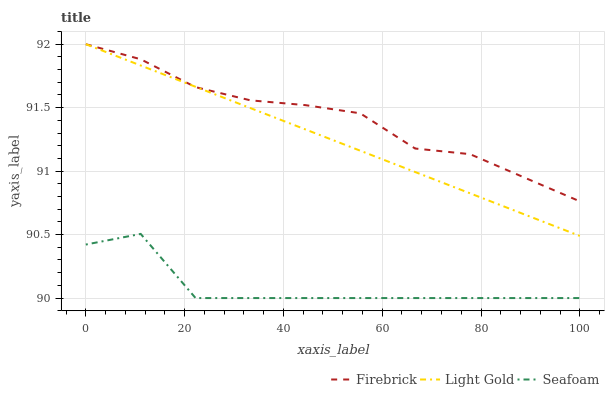Does Seafoam have the minimum area under the curve?
Answer yes or no. Yes. Does Firebrick have the maximum area under the curve?
Answer yes or no. Yes. Does Light Gold have the minimum area under the curve?
Answer yes or no. No. Does Light Gold have the maximum area under the curve?
Answer yes or no. No. Is Light Gold the smoothest?
Answer yes or no. Yes. Is Seafoam the roughest?
Answer yes or no. Yes. Is Seafoam the smoothest?
Answer yes or no. No. Is Light Gold the roughest?
Answer yes or no. No. Does Light Gold have the lowest value?
Answer yes or no. No. Does Light Gold have the highest value?
Answer yes or no. Yes. Does Seafoam have the highest value?
Answer yes or no. No. Is Seafoam less than Firebrick?
Answer yes or no. Yes. Is Light Gold greater than Seafoam?
Answer yes or no. Yes. Does Firebrick intersect Light Gold?
Answer yes or no. Yes. Is Firebrick less than Light Gold?
Answer yes or no. No. Is Firebrick greater than Light Gold?
Answer yes or no. No. Does Seafoam intersect Firebrick?
Answer yes or no. No. 